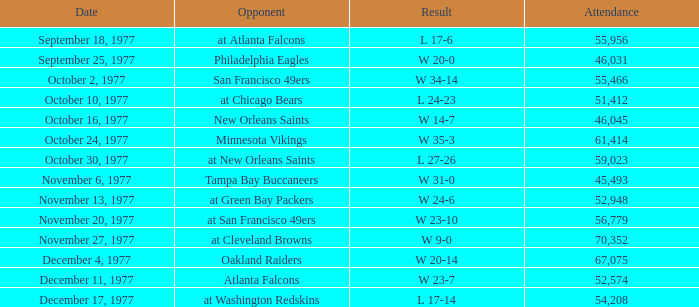What is the lowest attendance for week 2? 46031.0. Can you give me this table as a dict? {'header': ['Date', 'Opponent', 'Result', 'Attendance'], 'rows': [['September 18, 1977', 'at Atlanta Falcons', 'L 17-6', '55,956'], ['September 25, 1977', 'Philadelphia Eagles', 'W 20-0', '46,031'], ['October 2, 1977', 'San Francisco 49ers', 'W 34-14', '55,466'], ['October 10, 1977', 'at Chicago Bears', 'L 24-23', '51,412'], ['October 16, 1977', 'New Orleans Saints', 'W 14-7', '46,045'], ['October 24, 1977', 'Minnesota Vikings', 'W 35-3', '61,414'], ['October 30, 1977', 'at New Orleans Saints', 'L 27-26', '59,023'], ['November 6, 1977', 'Tampa Bay Buccaneers', 'W 31-0', '45,493'], ['November 13, 1977', 'at Green Bay Packers', 'W 24-6', '52,948'], ['November 20, 1977', 'at San Francisco 49ers', 'W 23-10', '56,779'], ['November 27, 1977', 'at Cleveland Browns', 'W 9-0', '70,352'], ['December 4, 1977', 'Oakland Raiders', 'W 20-14', '67,075'], ['December 11, 1977', 'Atlanta Falcons', 'W 23-7', '52,574'], ['December 17, 1977', 'at Washington Redskins', 'L 17-14', '54,208']]} 